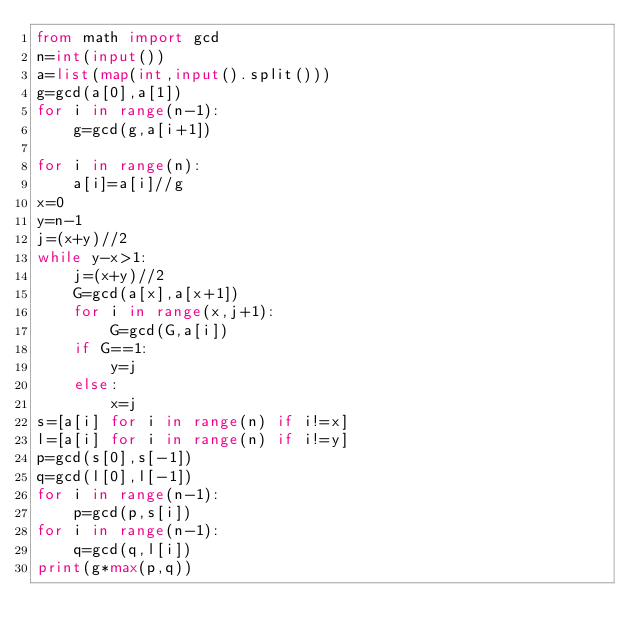Convert code to text. <code><loc_0><loc_0><loc_500><loc_500><_Python_>from math import gcd
n=int(input())
a=list(map(int,input().split()))
g=gcd(a[0],a[1])
for i in range(n-1):
    g=gcd(g,a[i+1])

for i in range(n):
    a[i]=a[i]//g
x=0
y=n-1
j=(x+y)//2
while y-x>1:
    j=(x+y)//2
    G=gcd(a[x],a[x+1])
    for i in range(x,j+1):
        G=gcd(G,a[i])
    if G==1:
        y=j
    else:
        x=j
s=[a[i] for i in range(n) if i!=x]
l=[a[i] for i in range(n) if i!=y]
p=gcd(s[0],s[-1])
q=gcd(l[0],l[-1])
for i in range(n-1):
    p=gcd(p,s[i])
for i in range(n-1):
    q=gcd(q,l[i])
print(g*max(p,q))
</code> 